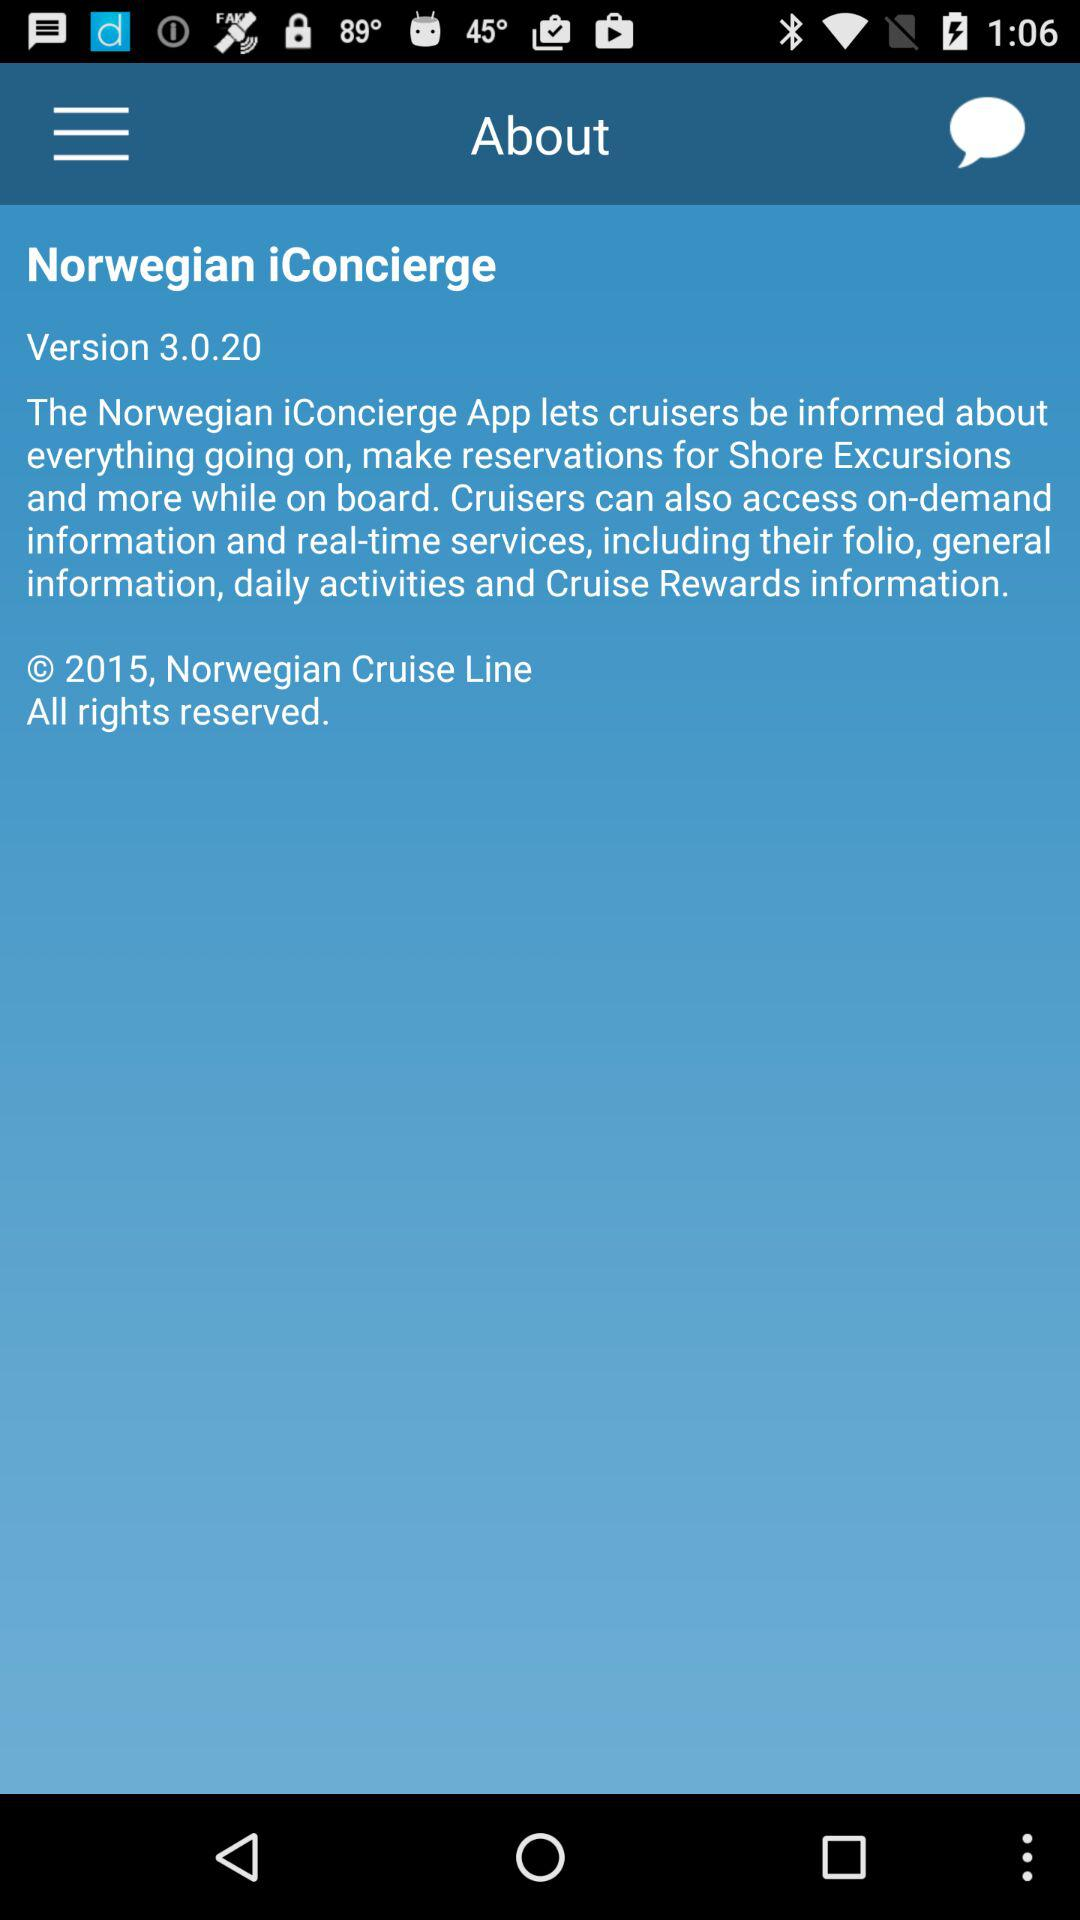What is the version of the application? The version of the application is 3.0.20. 